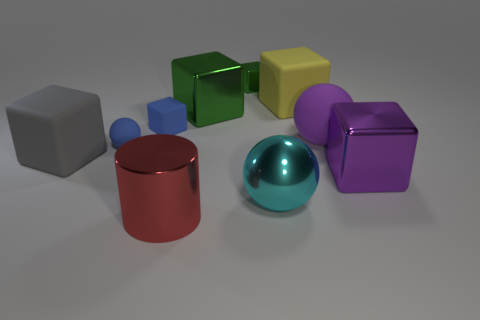There is a matte thing that is left of the metal ball and behind the tiny ball; what size is it? The object to the left of the metal ball and behind the tiny ball appears to be a medium-sized, matte-finish cube. Its scale is larger than the small sphere but smaller than the adjacent cubes and cylinder. 